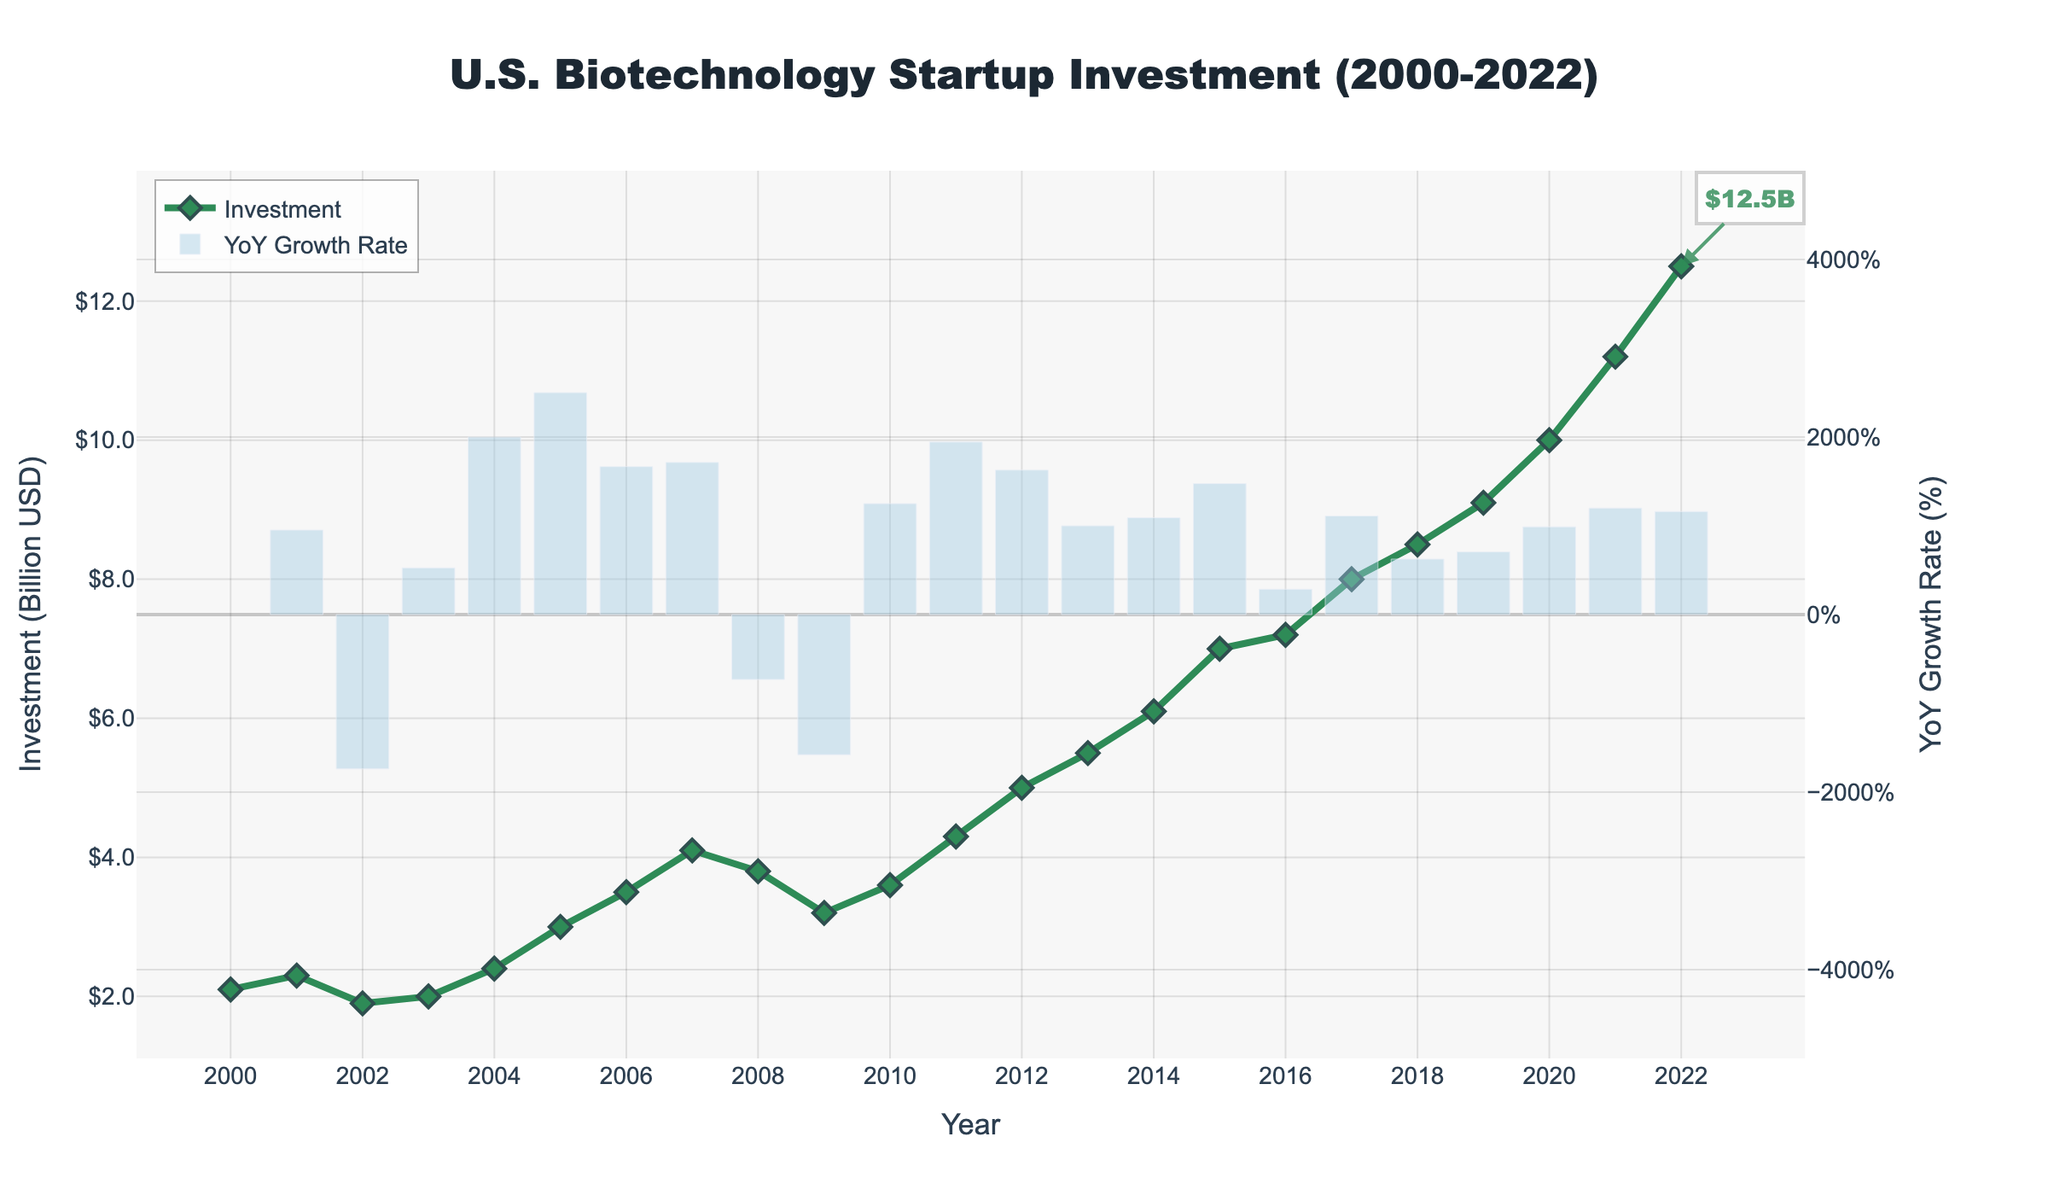What is the title of the plot? The title of the plot is prominently displayed at the top and reads "U.S. Biotechnology Startup Investment (2000-2022)."
Answer: U.S. Biotechnology Startup Investment (2000-2022) Which year had the highest investment in biotechnology startups? The highest investment level is shown on the line plot with a diamond marker at the year 2022, reaching $12.5 billion.
Answer: 2022 What's the year-over-year (YoY) growth rate of investment in 2022? The corresponding bar for 2022 shows the YoY growth rate. It appears to be approximately 12%.
Answer: ~12% How did the investment trend change from 2008 to 2009? To find the change, observe the line plot between these two years. The line goes down from $3.8 billion in 2008 to $3.2 billion in 2009, indicating a decrease.
Answer: Decreased What is the difference in investment between 2021 and 2022? To calculate the difference, find the investment values for 2021 and 2022 from the plot ($11.2 billion and $12.5 billion respectively) and subtract them. $12.5B - $11.2B = $1.3B.
Answer: $1.3 billion Which period saw the most consistent growth in investment? The most consistent growth can be observed by finding a continuous upward trend. From 2011 to 2021, there is a steady and consistent increase in investment each year.
Answer: 2011-2021 